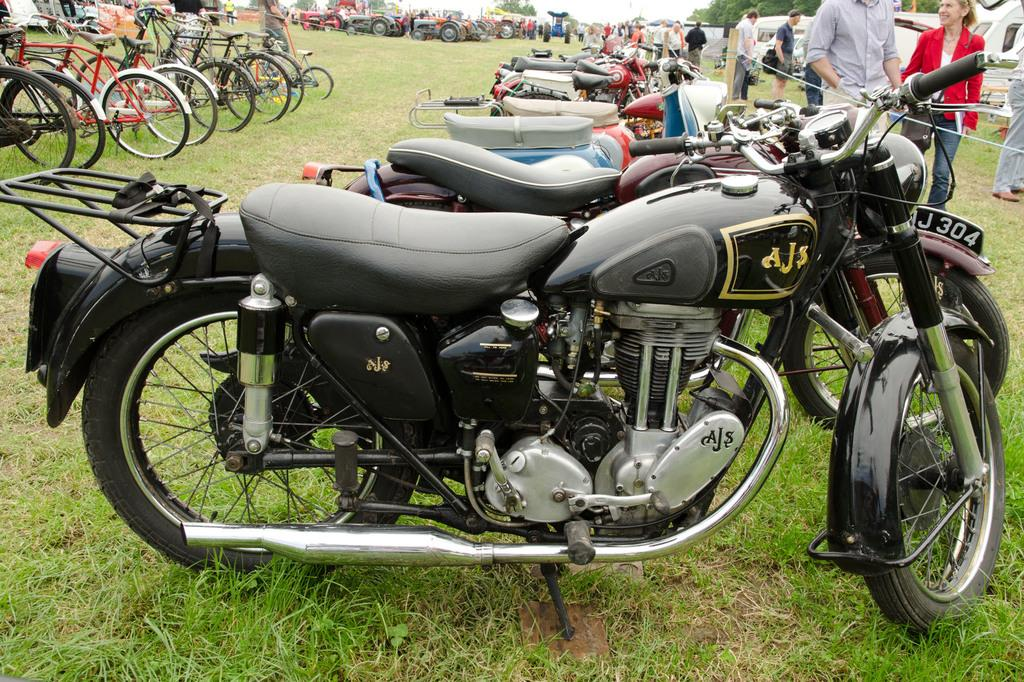What types of vehicles are present in the image? There are motorbikes, bicycles, and tractors in the image. Where are the vehicles located? The vehicles are parked on the grass. Are there any people in the image? Yes, there are people in the image. What can be seen in the background of the image? There are trees and the sky visible in the background of the image. What type of jam is being spread on the tank in the image? There is no tank or jam present in the image. How are the people pushing the push in the image? There is no push present in the image; the people are not pushing anything. 